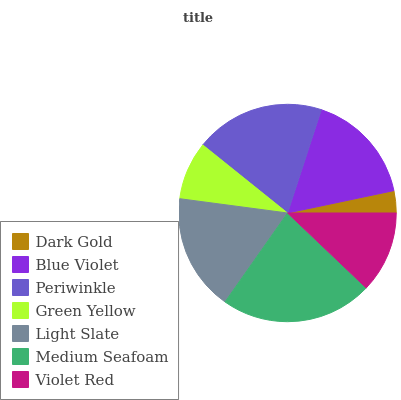Is Dark Gold the minimum?
Answer yes or no. Yes. Is Medium Seafoam the maximum?
Answer yes or no. Yes. Is Blue Violet the minimum?
Answer yes or no. No. Is Blue Violet the maximum?
Answer yes or no. No. Is Blue Violet greater than Dark Gold?
Answer yes or no. Yes. Is Dark Gold less than Blue Violet?
Answer yes or no. Yes. Is Dark Gold greater than Blue Violet?
Answer yes or no. No. Is Blue Violet less than Dark Gold?
Answer yes or no. No. Is Blue Violet the high median?
Answer yes or no. Yes. Is Blue Violet the low median?
Answer yes or no. Yes. Is Dark Gold the high median?
Answer yes or no. No. Is Dark Gold the low median?
Answer yes or no. No. 